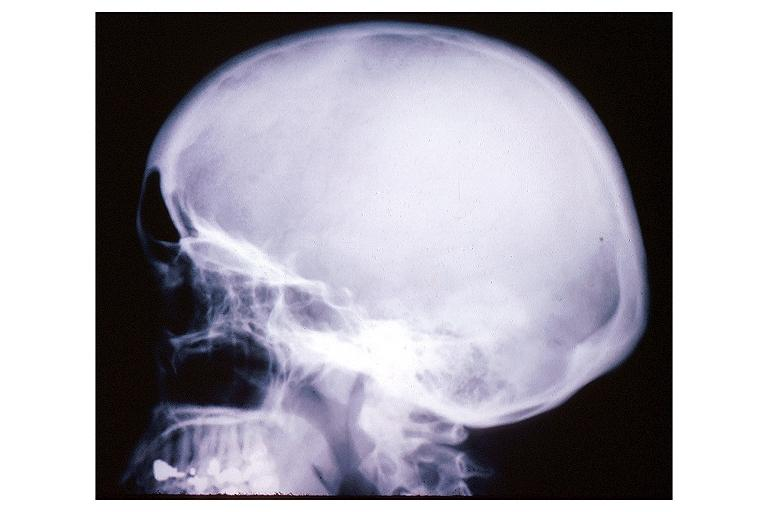what does this image show?
Answer the question using a single word or phrase. Pagets disease 